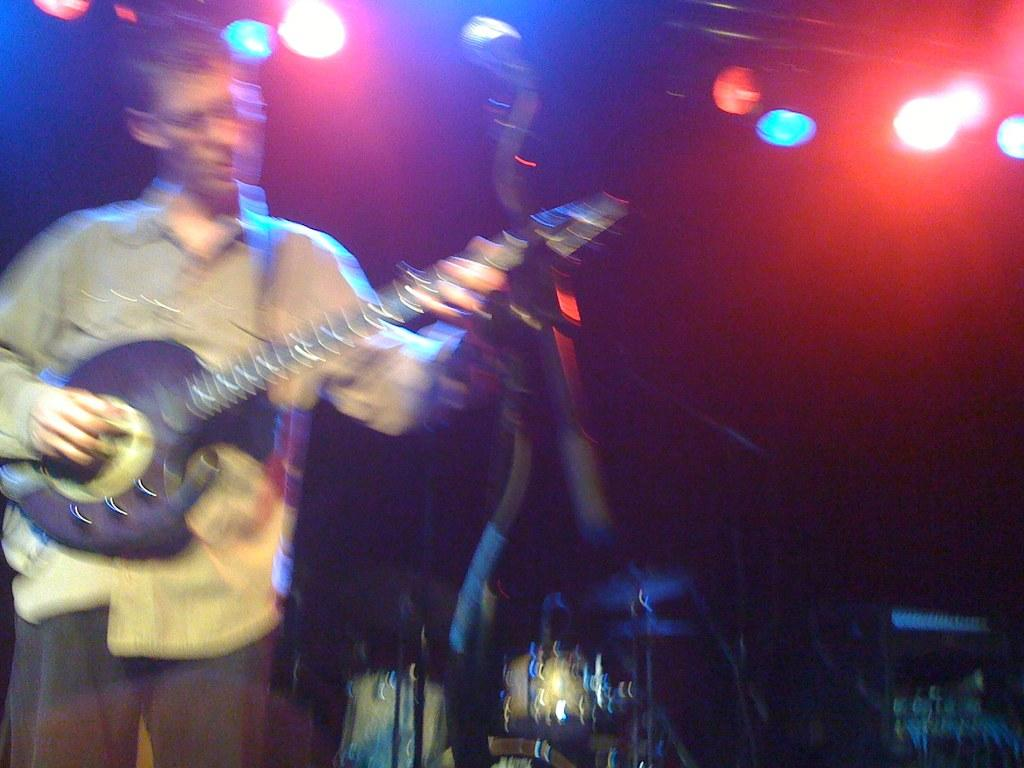What is the main subject of the image? There is a person in the image. What is the person wearing? The person is wearing a shirt and pants. What is the person holding in the image? The person is holding a guitar. What is the person doing with the guitar? The person is playing the guitar. What can be seen in the background of the image? There are lights in the background of the image. How many giants are visible in the image? There are no giants present in the image. What type of drink is the person holding in the image? The person is not holding a drink in the image; they are holding a guitar. 